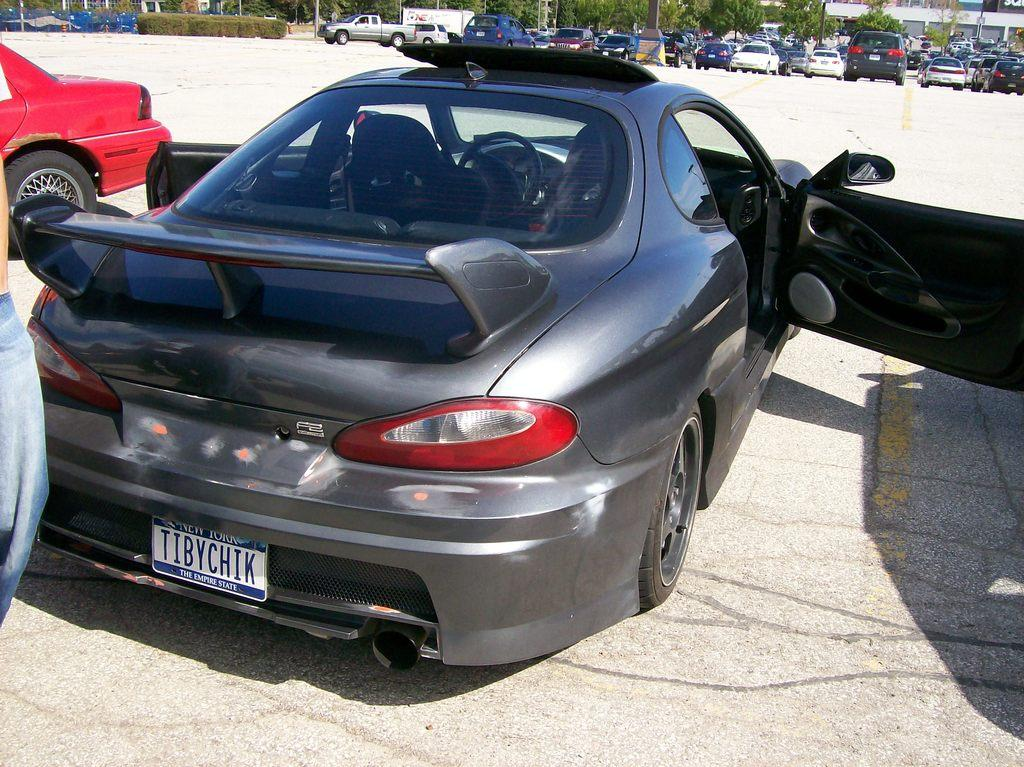What type of vehicles can be seen in the image? There are cars and a mini truck in the image. What other objects or features can be seen in the image? There are trees and a building in the image. What is the state of the car doors in the image? The car doors are opened in the image. Can you describe the human figure in the image? It appears that there is a human figure on the left side of the image. What type of root can be seen growing from the building in the image? There is no root growing from the building in the image. What belief system is represented by the cars in the image? The image does not depict any specific belief system; it simply shows cars and other objects. 